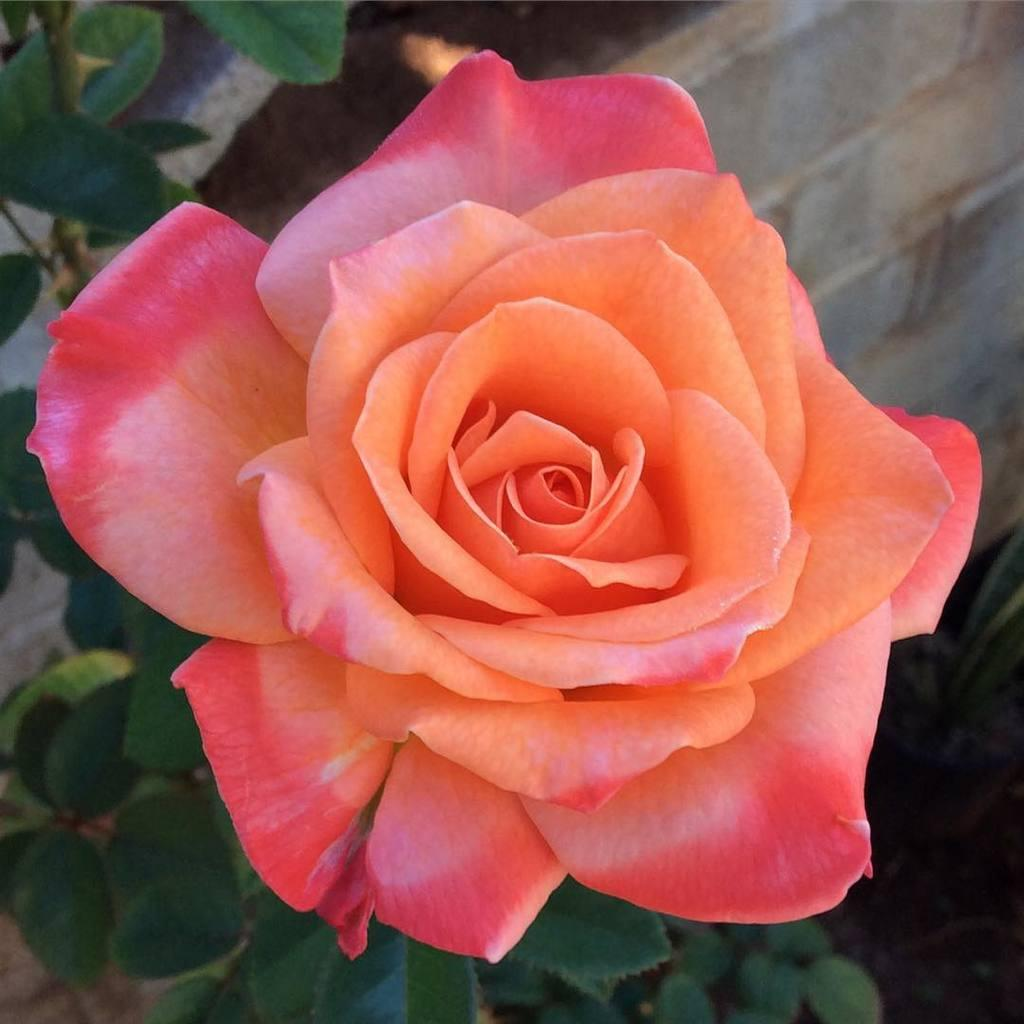What is the main subject of the image? The main subject of the image is a flower on a plant. Can you describe the colors of the flower? The flower has pink and orange colors. What can be seen in the background of the image? There is a wall in the background of the image. Is there another plant visible in the image? Yes, there is a plant at the bottom of the image. What type of wax can be seen dripping from the flower in the image? There is no wax present in the image, and therefore no wax can be seen dripping from the flower. 